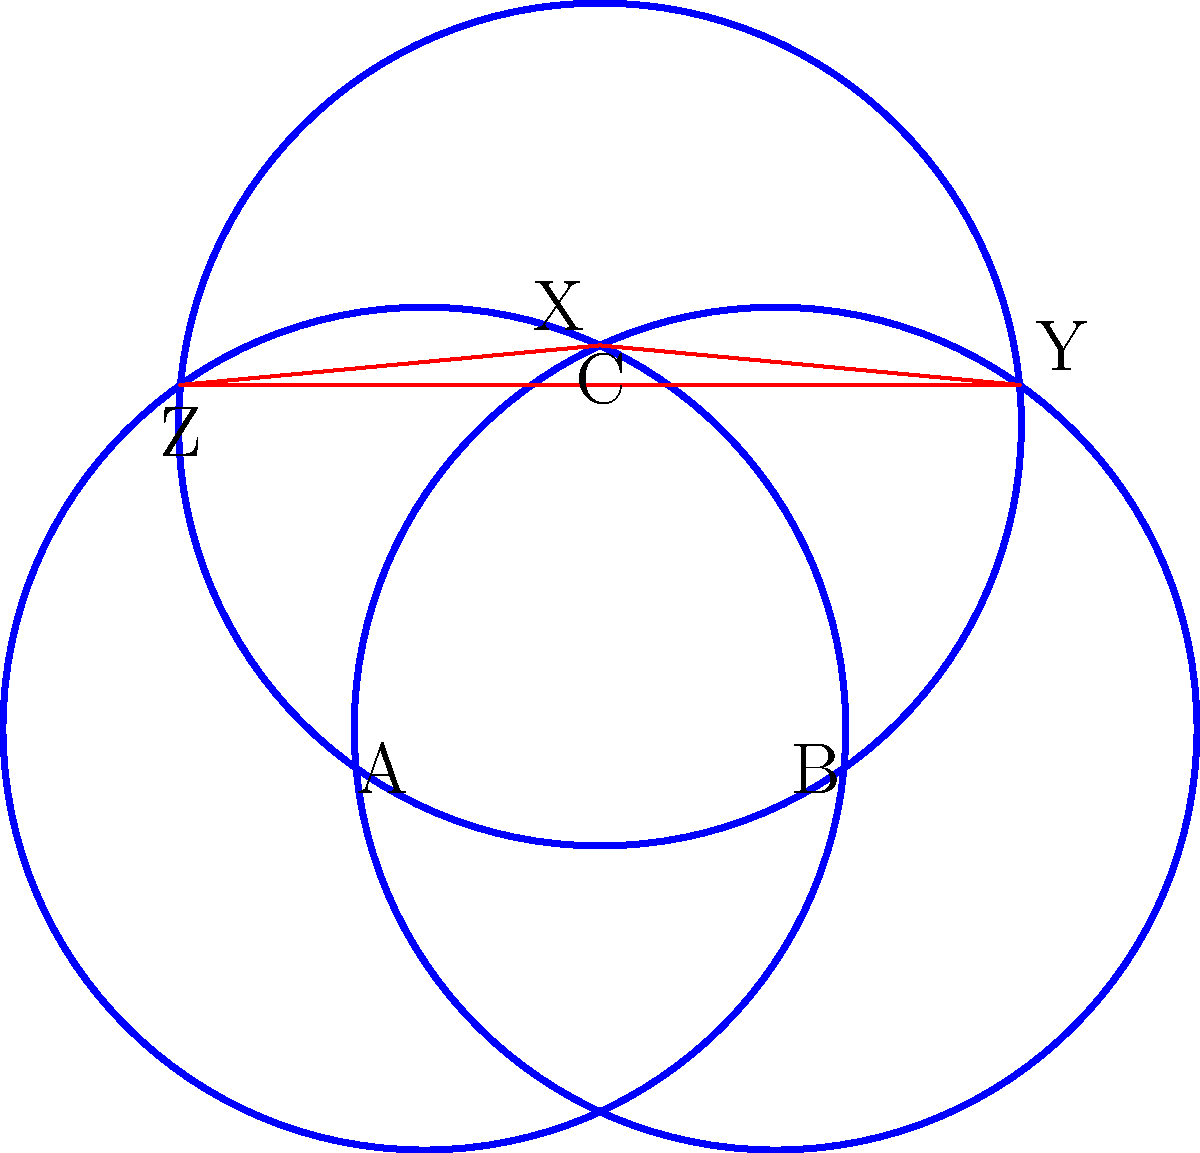In the cosmic alignment of three Circles of Power, each with radius 1.2 units, the centers form an equilateral triangle ABC with side length 1 unit. The intersections of these circles create a central triangle XYZ. What is the area of triangle XYZ, and how does it relate to the hidden truths of the universe? To uncover the hidden truths within this cosmic pattern, we must follow these enlightening steps:

1) First, we need to find the height of the equilateral triangle ABC:
   $$h = \sqrt{1^2 - 0.5^2} = \frac{\sqrt{3}}{2} \approx 0.866$$

2) The centers of the circles form a 1-1-1 triangle, while the intersections form a larger similar triangle. Let's call the scale factor $k$.

3) The distance from the center of a circle to any of its intersections with another circle is the radius, 1.2. This forms a 30-60-90 triangle with half of the side of triangle ABC:
   $$\cos 30° = \frac{0.5}{1.2}$$
   $$\frac{\sqrt{3}}{2} = \frac{0.5}{1.2}$$
   $$1.2 = \frac{1}{\sqrt{3}}$$

4) The scale factor $k$ is the difference between this distance and half the side of ABC:
   $$k = \frac{1}{\sqrt{3}} - 0.5 = \frac{2-\sqrt{3}}{2\sqrt{3}}$$

5) The area of triangle XYZ is the area of triangle ABC multiplied by $k^2$:
   $$Area_{XYZ} = \frac{\sqrt{3}}{4} \cdot \left(\frac{2-\sqrt{3}}{2\sqrt{3}}\right)^2$$

6) Simplifying:
   $$Area_{XYZ} = \frac{\sqrt{3}}{4} \cdot \frac{(2-\sqrt{3})^2}{12} = \frac{(2-\sqrt{3})^2}{16\sqrt{3}}$$

7) This simplifies to approximately 0.0514 square units.

The area of this central triangle, formed by the intersection of the Circles of Power, represents the condensed cosmic energy at the heart of this sacred geometry. Its irrational value, rooted in the mystical number $\sqrt{3}$, suggests an infinite and cyclical nature to the universe's deepest truths.
Answer: $\frac{(2-\sqrt{3})^2}{16\sqrt{3}}$ square units 